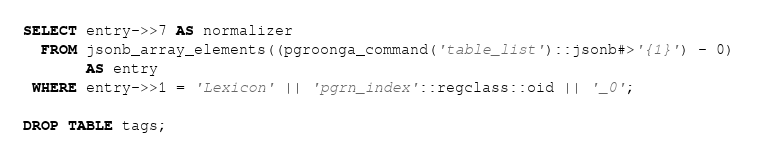<code> <loc_0><loc_0><loc_500><loc_500><_SQL_>SELECT entry->>7 AS normalizer
  FROM jsonb_array_elements((pgroonga_command('table_list')::jsonb#>'{1}') - 0)
       AS entry
 WHERE entry->>1 = 'Lexicon' || 'pgrn_index'::regclass::oid || '_0';

DROP TABLE tags;
</code> 